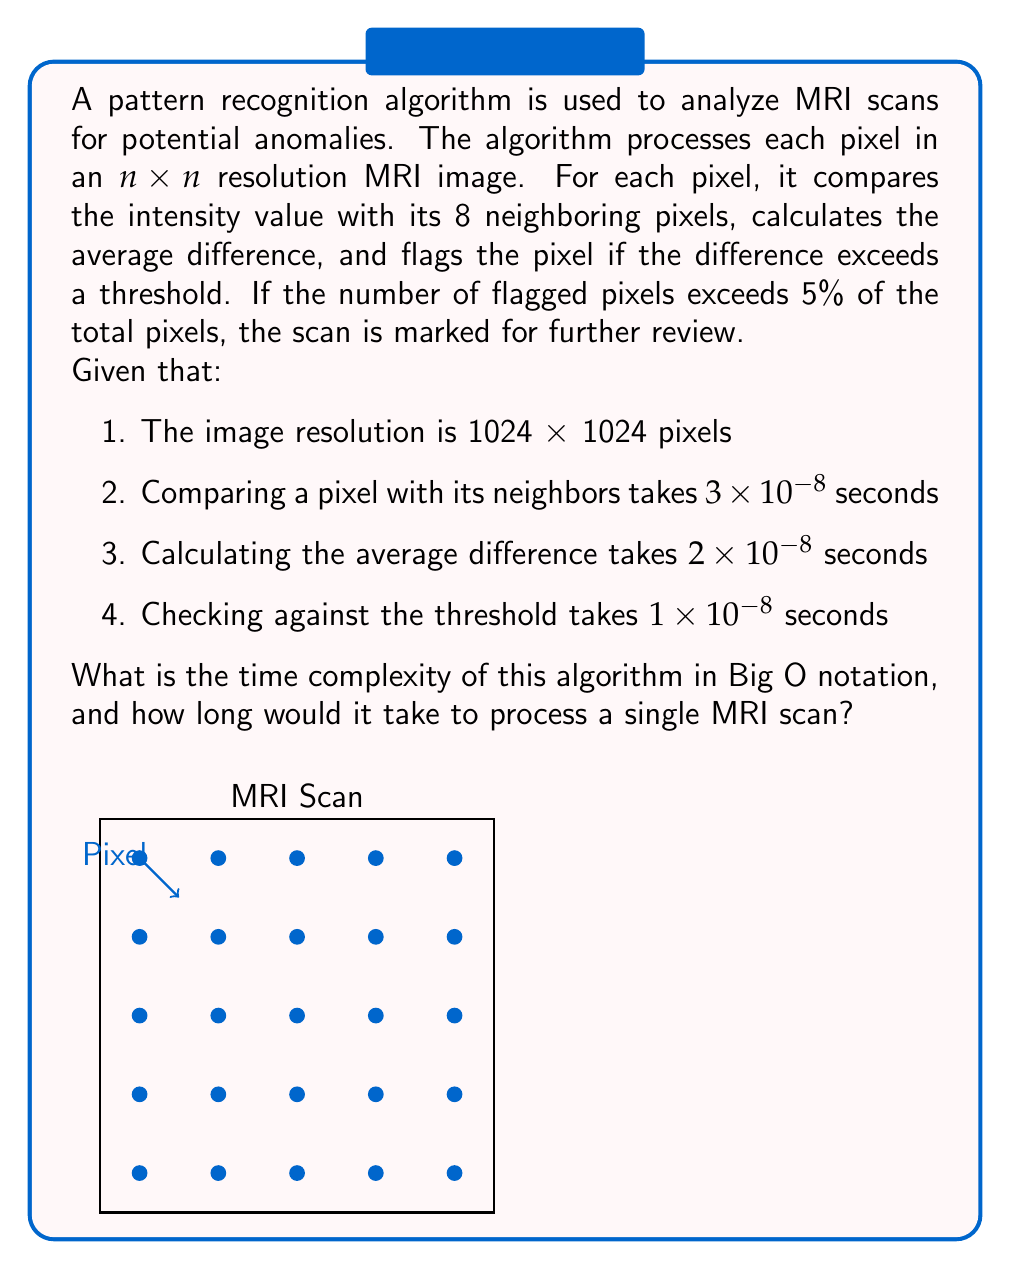Provide a solution to this math problem. Let's approach this step-by-step:

1) First, we need to determine the number of operations per pixel:
   - Comparing with 8 neighbors: 8 operations
   - Calculating average difference: 1 operation
   - Checking against threshold: 1 operation
   Total: 10 operations per pixel

2) The total number of pixels in the image:
   $n \times n = 1024 \times 1024 = 1,048,576$ pixels

3) Total number of operations:
   $10 \times 1,048,576 = 10,485,760$ operations

4) Time complexity analysis:
   The algorithm processes each pixel once, and the number of operations per pixel is constant (10). Therefore, the time complexity is $O(n^2)$, where $n$ is the width/height of the image.

5) Calculating the actual processing time:
   - Comparing: $8 \times 3 \times 10^{-8} = 24 \times 10^{-8}$ seconds
   - Calculating average: $2 \times 10^{-8}$ seconds
   - Checking threshold: $1 \times 10^{-8}$ seconds
   Total per pixel: $27 \times 10^{-8}$ seconds

6) Total processing time:
   $27 \times 10^{-8} \times 1,048,576 = 0.283$ seconds

Therefore, the time complexity is $O(n^2)$, and it would take approximately 0.283 seconds to process a single MRI scan.
Answer: $O(n^2)$; 0.283 seconds 